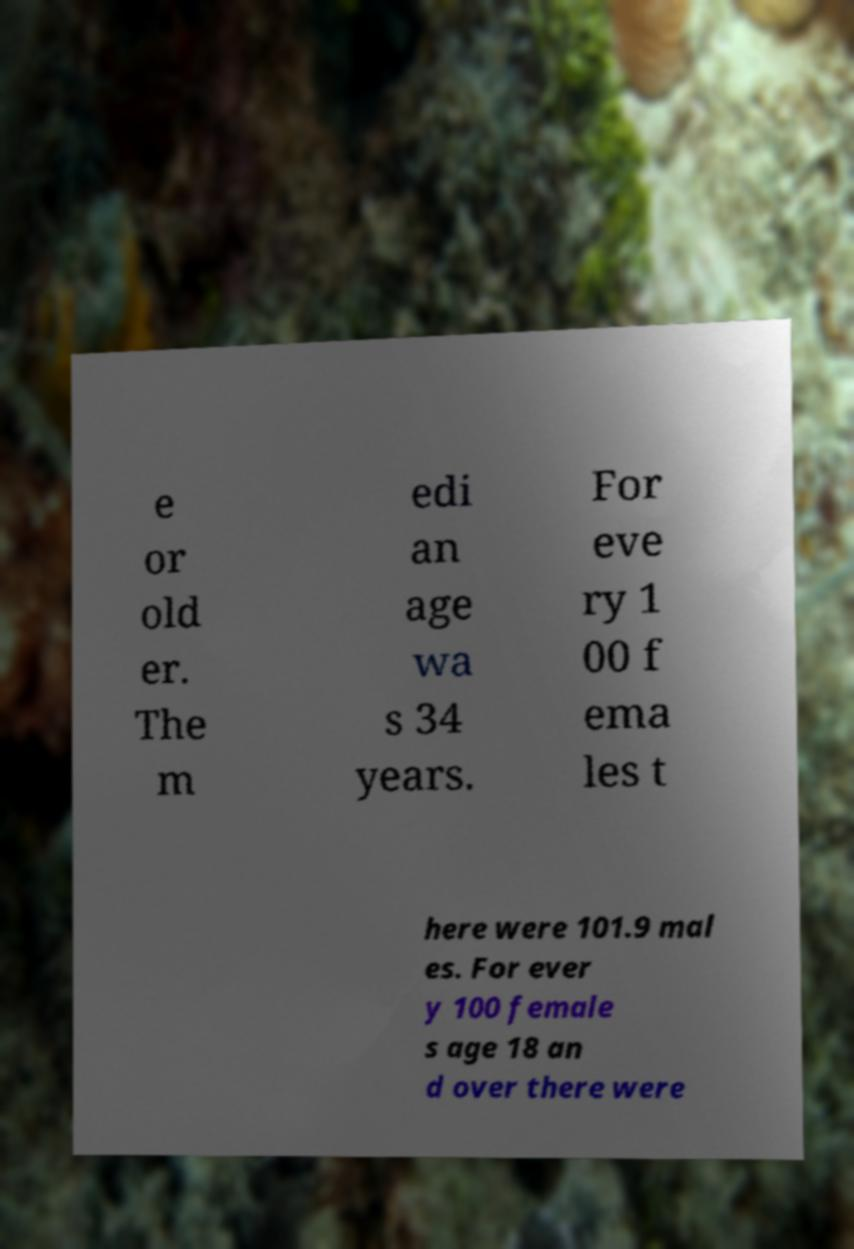Please identify and transcribe the text found in this image. e or old er. The m edi an age wa s 34 years. For eve ry 1 00 f ema les t here were 101.9 mal es. For ever y 100 female s age 18 an d over there were 